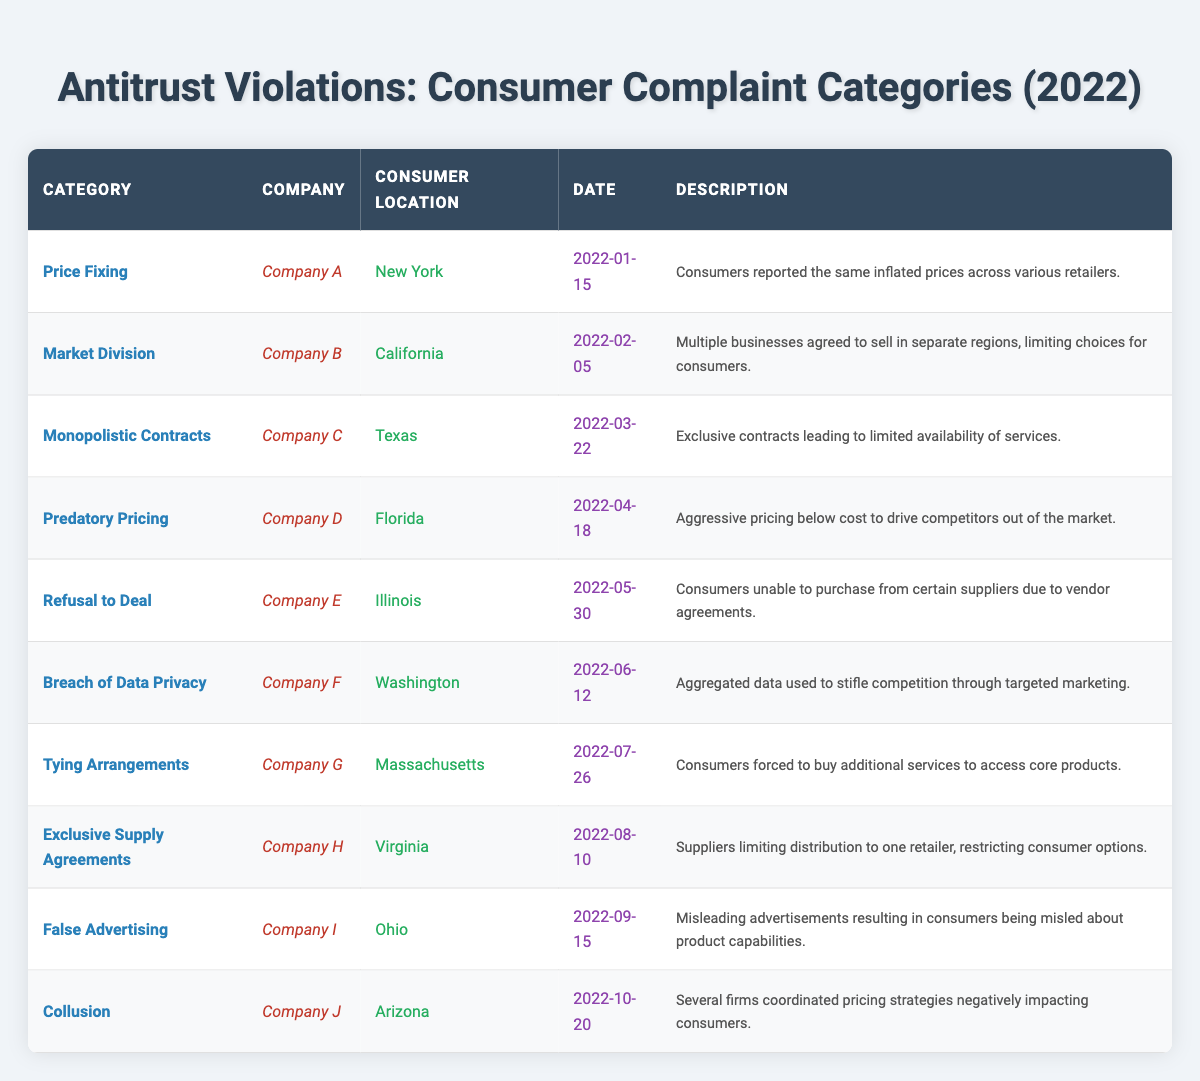What is the total number of complaints recorded in 2022? There are ten entries in the complaints list, each representing one complaint. Therefore, the total number of complaints is 10.
Answer: 10 Which company is associated with the "Breach of Data Privacy" complaint? According to the table, the "Breach of Data Privacy" complaint is associated with "Company F".
Answer: Company F In which consumer location did the "Predatory Pricing" incident occur? The "Predatory Pricing" complaint is listed under "Florida" as the consumer location.
Answer: Florida How many different complaint categories are listed in the table? The table displays 10 unique categories, each represented by a different row. Thus, there are 10 categories.
Answer: 10 Did any complaints involve "False Advertising"? Yes, there is a complaint specifically categorized as "False Advertising" from "Company I" in "Ohio".
Answer: Yes Which complaint category was reported first in the year 2022? The complaint reported first is "Price Fixing" from "Company A" on January 15, 2022. It is the earliest date in the table.
Answer: Price Fixing What percentage of complaints are related to "Exclusive Supply Agreements" and "Market Division"? Both "Exclusive Supply Agreements" and "Market Division" are each one complaint out of a total of 10 complaints. Therefore, (2/10)*100 = 20%.
Answer: 20% List the complaint categories that occurred in the second quarter of 2022 (April to June). The complaints in the second quarter of 2022 are "Predatory Pricing" in April, "Refusal to Deal" in May, and "Breach of Data Privacy" in June. This totals to three complaints in that quarter.
Answer: Predatory Pricing, Refusal to Deal, Breach of Data Privacy Was there a complaint involving "Tying Arrangements" in the state of Massachusetts? Yes, "Tying Arrangements" was reported concerning "Company G" located in "Massachusetts".
Answer: Yes What is the most common complaint category among the recorded incidents? Each category has only one recorded incident, hence there is no common category. All categories are unique.
Answer: None 